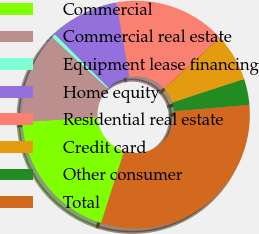<chart> <loc_0><loc_0><loc_500><loc_500><pie_chart><fcel>Commercial<fcel>Commercial real estate<fcel>Equipment lease financing<fcel>Home equity<fcel>Residential real estate<fcel>Credit card<fcel>Other consumer<fcel>Total<nl><fcel>19.02%<fcel>12.88%<fcel>0.6%<fcel>9.81%<fcel>15.95%<fcel>6.74%<fcel>3.67%<fcel>31.31%<nl></chart> 